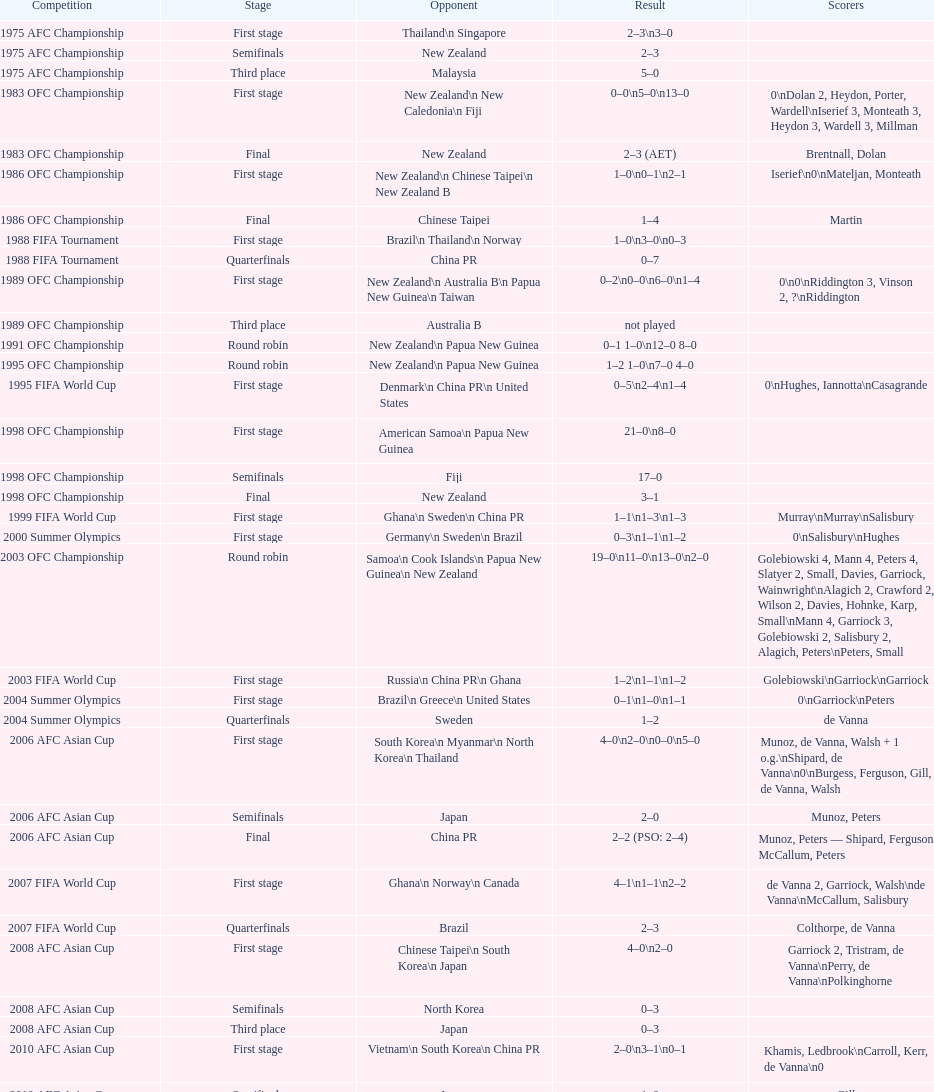How many phases were round robins? 3. 